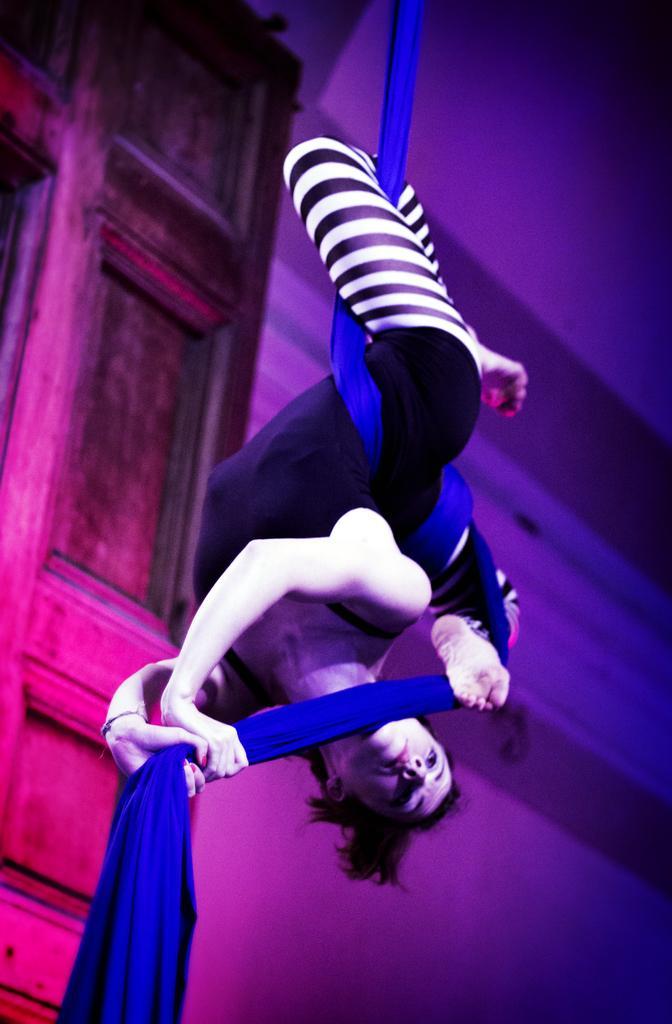Can you describe this image briefly? Here we can see a woman holding a cloth. In the background there is a door and a wall. 